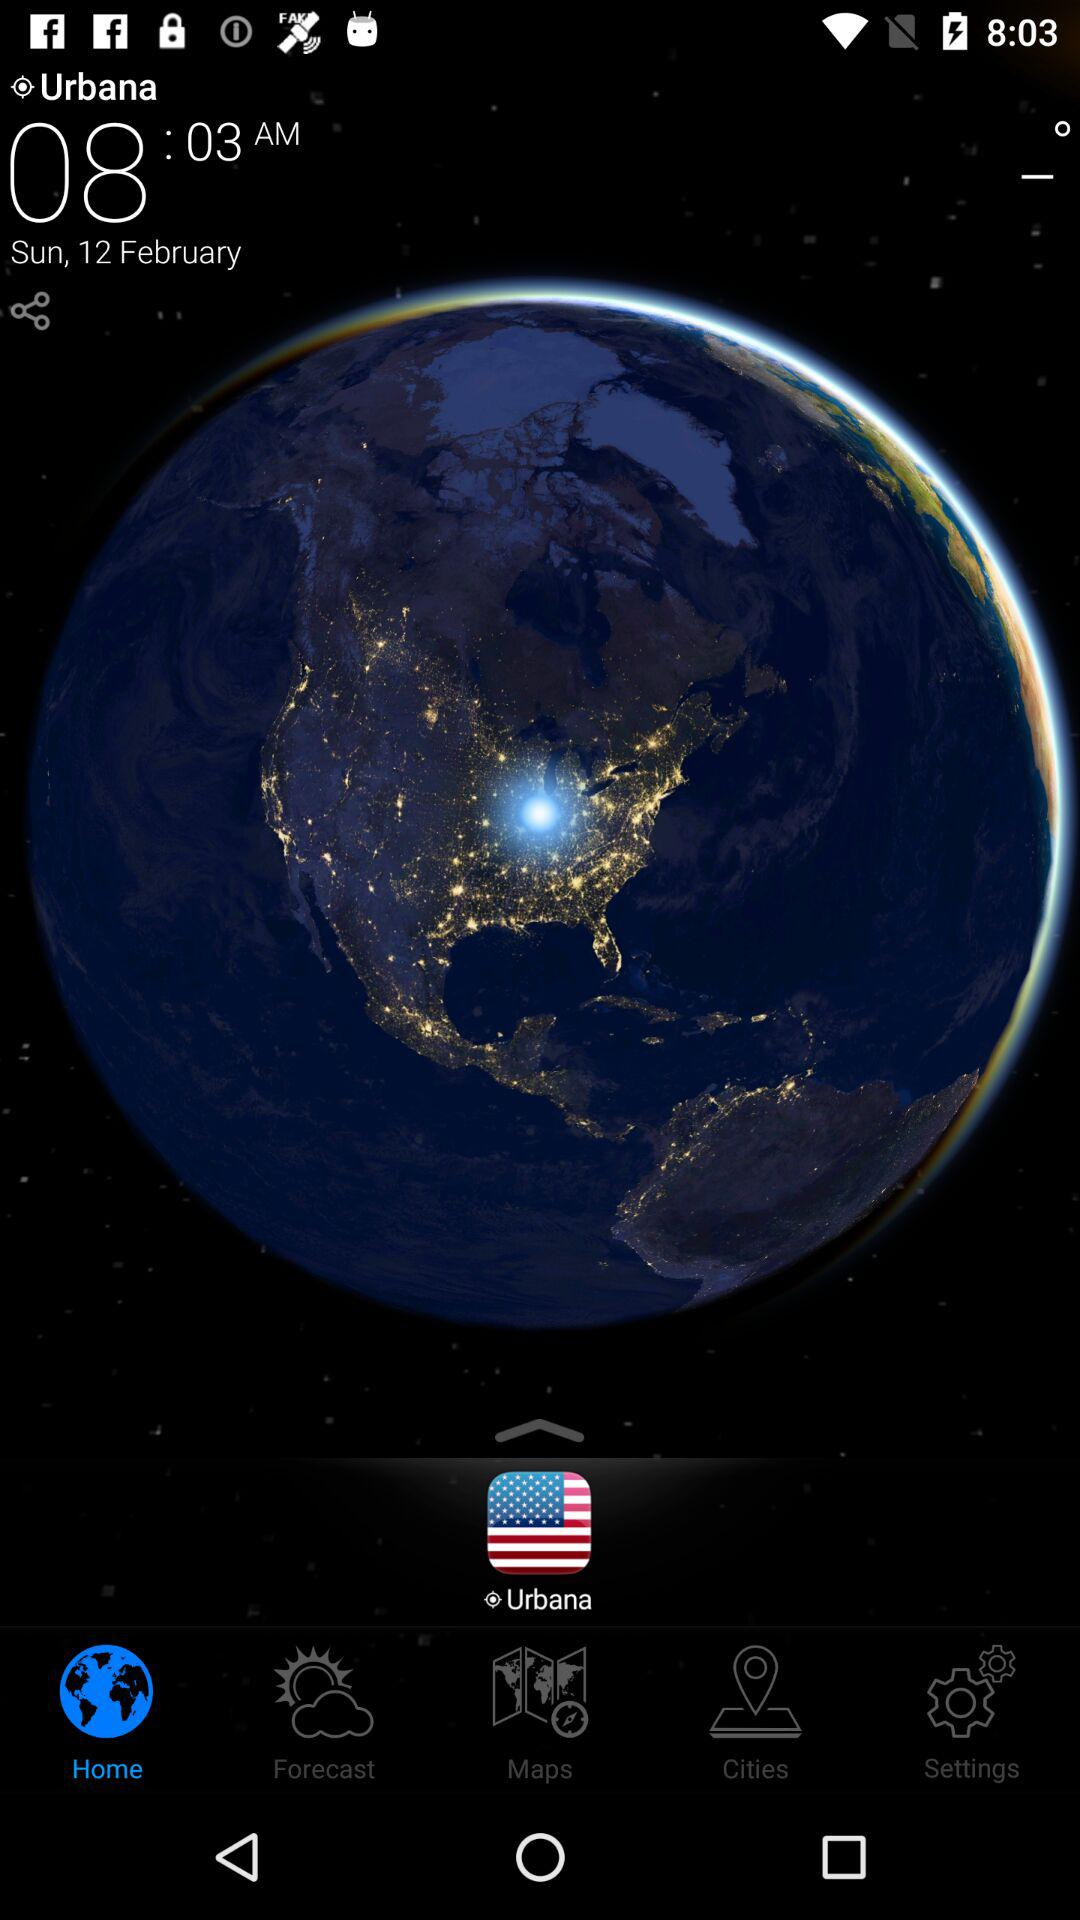What is the date? The date is Sunday, February 12. 